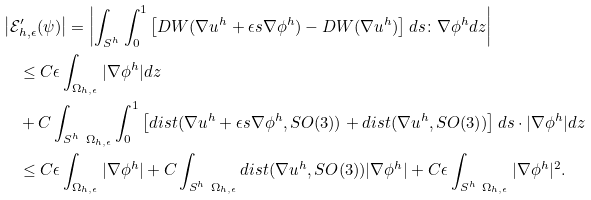Convert formula to latex. <formula><loc_0><loc_0><loc_500><loc_500>& \left | \mathcal { E } ^ { \prime } _ { h , \epsilon } ( \psi ) \right | = \left | \int _ { S ^ { h } } \int _ { 0 } ^ { 1 } \left [ D W ( \nabla u ^ { h } + \epsilon s \nabla \phi ^ { h } ) - D W ( \nabla u ^ { h } ) \right ] d s \colon \nabla \phi ^ { h } d z \right | \\ & \quad \leq C \epsilon \int _ { \Omega _ { h , \epsilon } } | \nabla \phi ^ { h } | d z \\ & \quad + C \int _ { S ^ { h } \ \Omega _ { h , \epsilon } } \int _ { 0 } ^ { 1 } \left [ d i s t ( \nabla u ^ { h } + \epsilon s \nabla \phi ^ { h } , S O ( 3 ) ) + d i s t ( \nabla u ^ { h } , S O ( 3 ) ) \right ] d s \cdot | \nabla \phi ^ { h } | d z \\ & \quad \leq C \epsilon \int _ { \Omega _ { h , \epsilon } } | \nabla \phi ^ { h } | + C \int _ { S ^ { h } \ \Omega _ { h , \epsilon } } d i s t ( \nabla u ^ { h } , S O ( 3 ) ) | \nabla \phi ^ { h } | + C \epsilon \int _ { S ^ { h } \ \Omega _ { h , \epsilon } } | \nabla \phi ^ { h } | ^ { 2 } .</formula> 